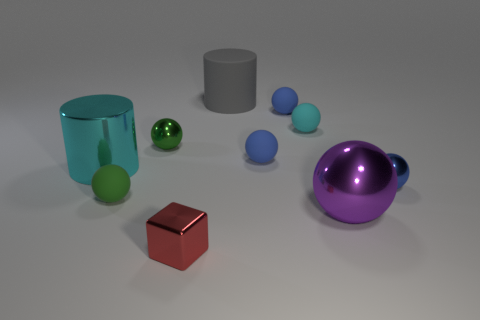What is the shape of the big cyan metallic object? The large cyan object in the image has a cylindrical shape. This form is characterized by its long, circular cross-sectional profile which is evident from its smooth, curved surface extending vertically. 